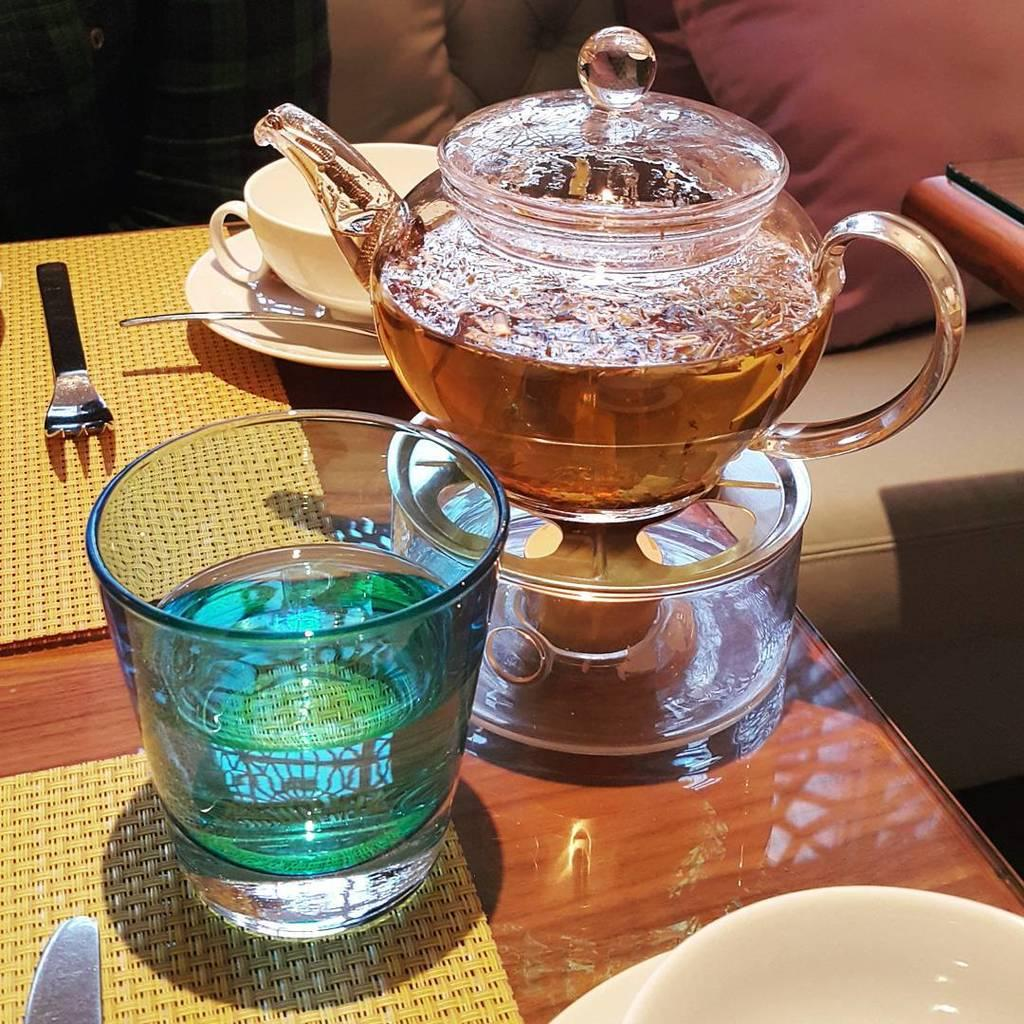What type of glassware is on the table in the image? There is a water glass on the table. What other tableware can be seen on the table? There is a tea bowl, a cup, a saucer, a box, a bowl, a plate, a knife, a fork, and a spoon on the table. What is placed under some of the tableware? There is a mat on the table. Is there any furniture visible in the image besides the table? Yes, there is a couch in the top right corner of the image. What is on the couch? There is a pillow on the couch. What month is depicted in the image? The image does not depict a month; it shows a table with various tableware and a couch with a pillow. Can you see a basketball in the image? There is no basketball present in the image. 